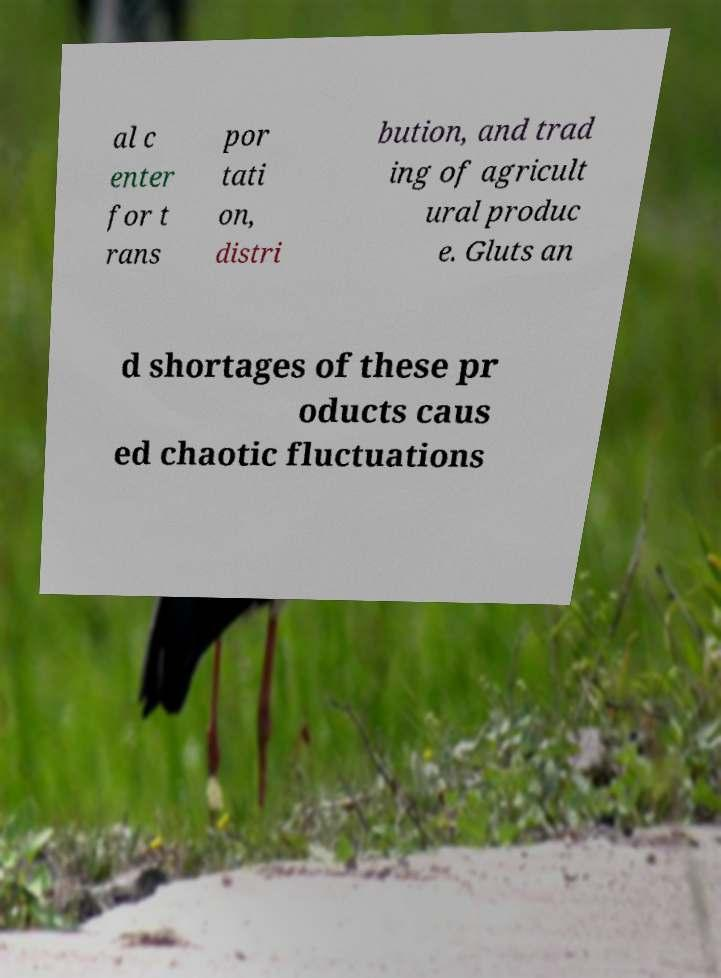Can you read and provide the text displayed in the image?This photo seems to have some interesting text. Can you extract and type it out for me? al c enter for t rans por tati on, distri bution, and trad ing of agricult ural produc e. Gluts an d shortages of these pr oducts caus ed chaotic fluctuations 